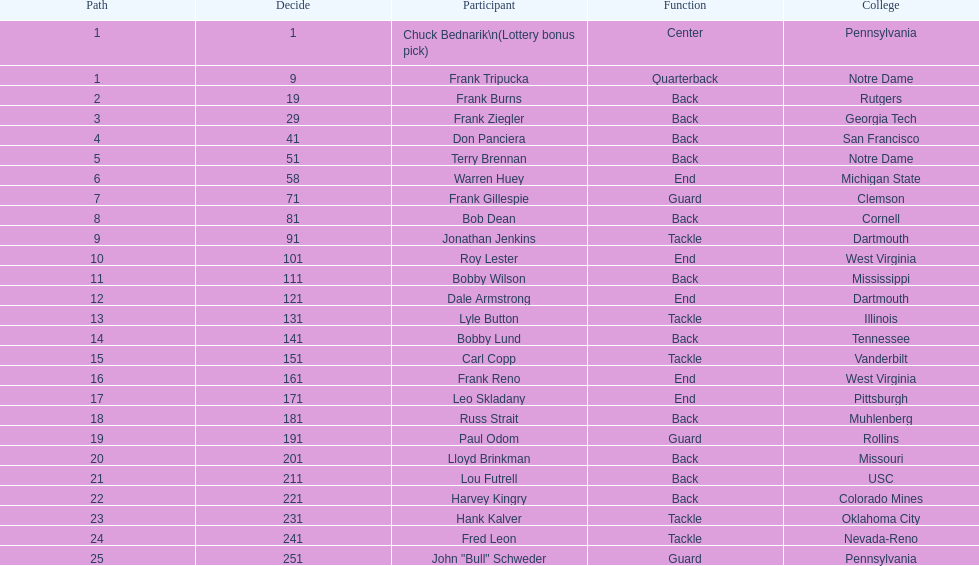Who was the player that the team drafted after bob dean? Jonathan Jenkins. 